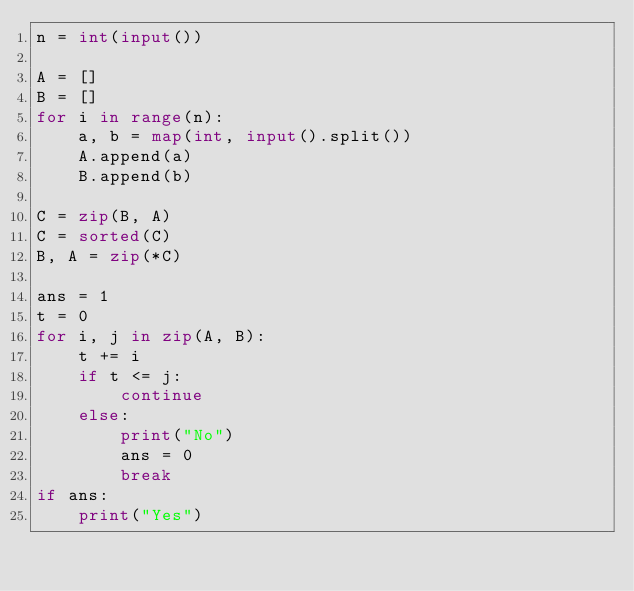Convert code to text. <code><loc_0><loc_0><loc_500><loc_500><_Python_>n = int(input())

A = []
B = []
for i in range(n):
    a, b = map(int, input().split())
    A.append(a)
    B.append(b)

C = zip(B, A)
C = sorted(C)
B, A = zip(*C)

ans = 1
t = 0
for i, j in zip(A, B):
    t += i
    if t <= j:
        continue
    else:
        print("No")
        ans = 0
        break
if ans:
    print("Yes")</code> 